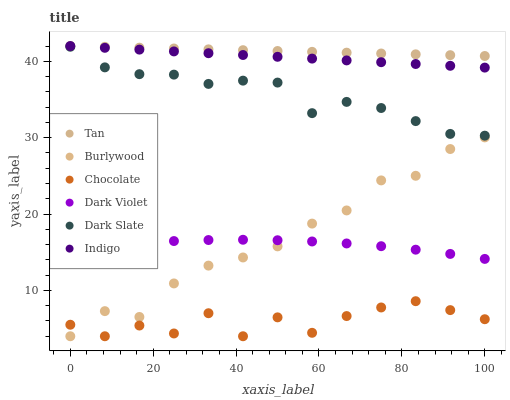Does Chocolate have the minimum area under the curve?
Answer yes or no. Yes. Does Tan have the maximum area under the curve?
Answer yes or no. Yes. Does Burlywood have the minimum area under the curve?
Answer yes or no. No. Does Burlywood have the maximum area under the curve?
Answer yes or no. No. Is Tan the smoothest?
Answer yes or no. Yes. Is Chocolate the roughest?
Answer yes or no. Yes. Is Burlywood the smoothest?
Answer yes or no. No. Is Burlywood the roughest?
Answer yes or no. No. Does Burlywood have the lowest value?
Answer yes or no. Yes. Does Dark Violet have the lowest value?
Answer yes or no. No. Does Tan have the highest value?
Answer yes or no. Yes. Does Burlywood have the highest value?
Answer yes or no. No. Is Burlywood less than Tan?
Answer yes or no. Yes. Is Dark Slate greater than Dark Violet?
Answer yes or no. Yes. Does Indigo intersect Tan?
Answer yes or no. Yes. Is Indigo less than Tan?
Answer yes or no. No. Is Indigo greater than Tan?
Answer yes or no. No. Does Burlywood intersect Tan?
Answer yes or no. No. 